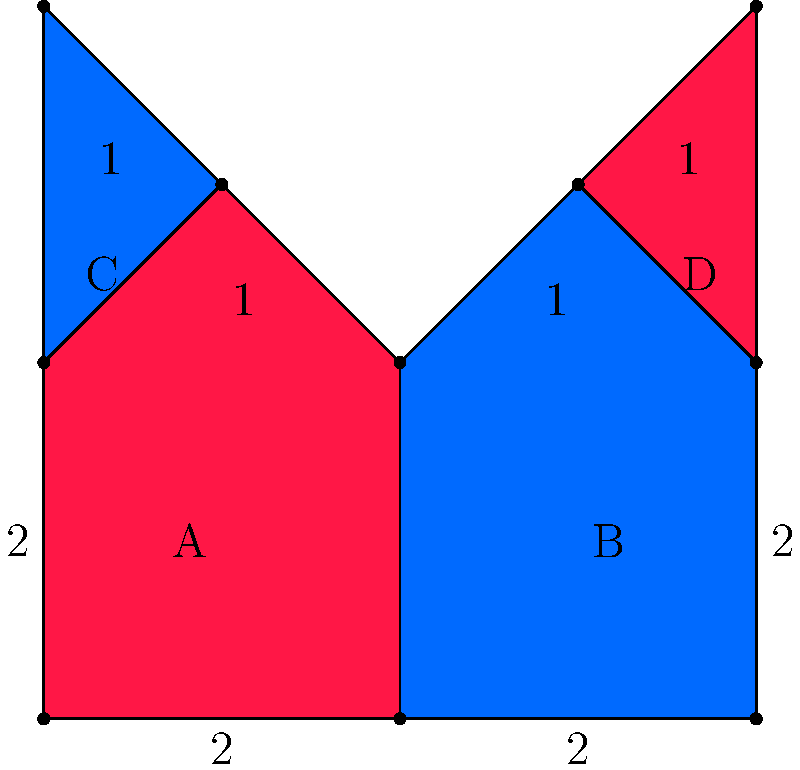In your latest short story inspired by Slavic folklore, you've designed a magical embroidery pattern resembling traditional motifs. The pattern consists of four irregular polygons (A, B, C, and D) as shown in the figure. Given that each small square in the grid represents 1 unit, calculate the total area of this enchanted embroidery design. How might the symbolism of this geometric pattern enhance the mystical elements in your story? Let's calculate the area of each polygon separately:

1. Polygons A and B:
   These are identical rectangles with an added triangle on top.
   Rectangle area: $2 \times 2 = 4$ sq units
   Triangle area: $\frac{1}{2} \times 2 \times 1 = 1$ sq unit
   Area of A = Area of B = $4 + 1 = 5$ sq units

2. Polygons C and D:
   These are identical right triangles.
   Area of C = Area of D = $\frac{1}{2} \times 1 \times 2 = 1$ sq unit

3. Total area:
   $$\text{Total Area} = \text{Area A} + \text{Area B} + \text{Area C} + \text{Area D}$$
   $$= 5 + 5 + 1 + 1 = 12\text{ sq units}$$

The symmetry and balance in this design, with its mirrored shapes and alternating colors, could symbolize the duality often found in Slavic folklore. The pointed shapes might represent protection or warding off evil spirits, while the overall pattern could be seen as a magical seal or emblem, enhancing the mystical elements of your story.
Answer: 12 square units 